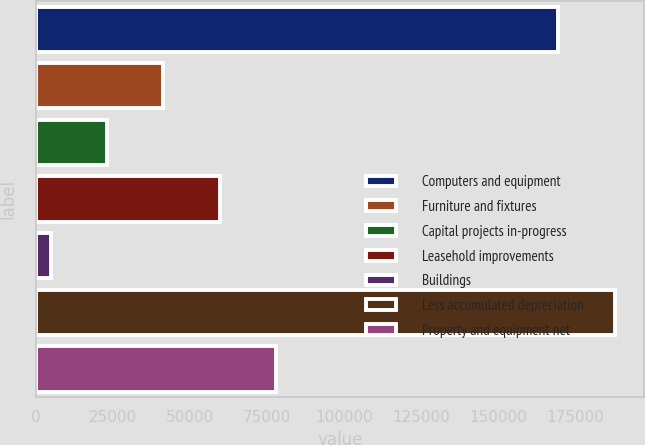Convert chart. <chart><loc_0><loc_0><loc_500><loc_500><bar_chart><fcel>Computers and equipment<fcel>Furniture and fixtures<fcel>Capital projects in-progress<fcel>Leasehold improvements<fcel>Buildings<fcel>Less accumulated depreciation<fcel>Property and equipment net<nl><fcel>169455<fcel>41357<fcel>23056.5<fcel>59657.5<fcel>4756<fcel>187761<fcel>77958<nl></chart> 